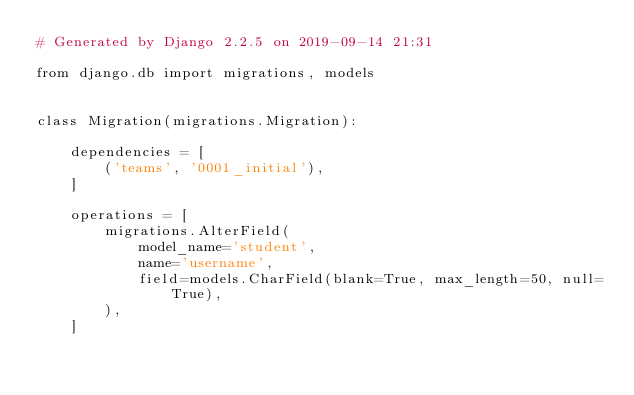<code> <loc_0><loc_0><loc_500><loc_500><_Python_># Generated by Django 2.2.5 on 2019-09-14 21:31

from django.db import migrations, models


class Migration(migrations.Migration):

    dependencies = [
        ('teams', '0001_initial'),
    ]

    operations = [
        migrations.AlterField(
            model_name='student',
            name='username',
            field=models.CharField(blank=True, max_length=50, null=True),
        ),
    ]
</code> 